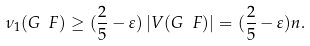<formula> <loc_0><loc_0><loc_500><loc_500>\nu _ { 1 } ( G \ F ) \geq ( \frac { 2 } { 5 } - \varepsilon ) \left | V ( G \ F ) \right | = ( \frac { 2 } { 5 } - \varepsilon ) n .</formula> 